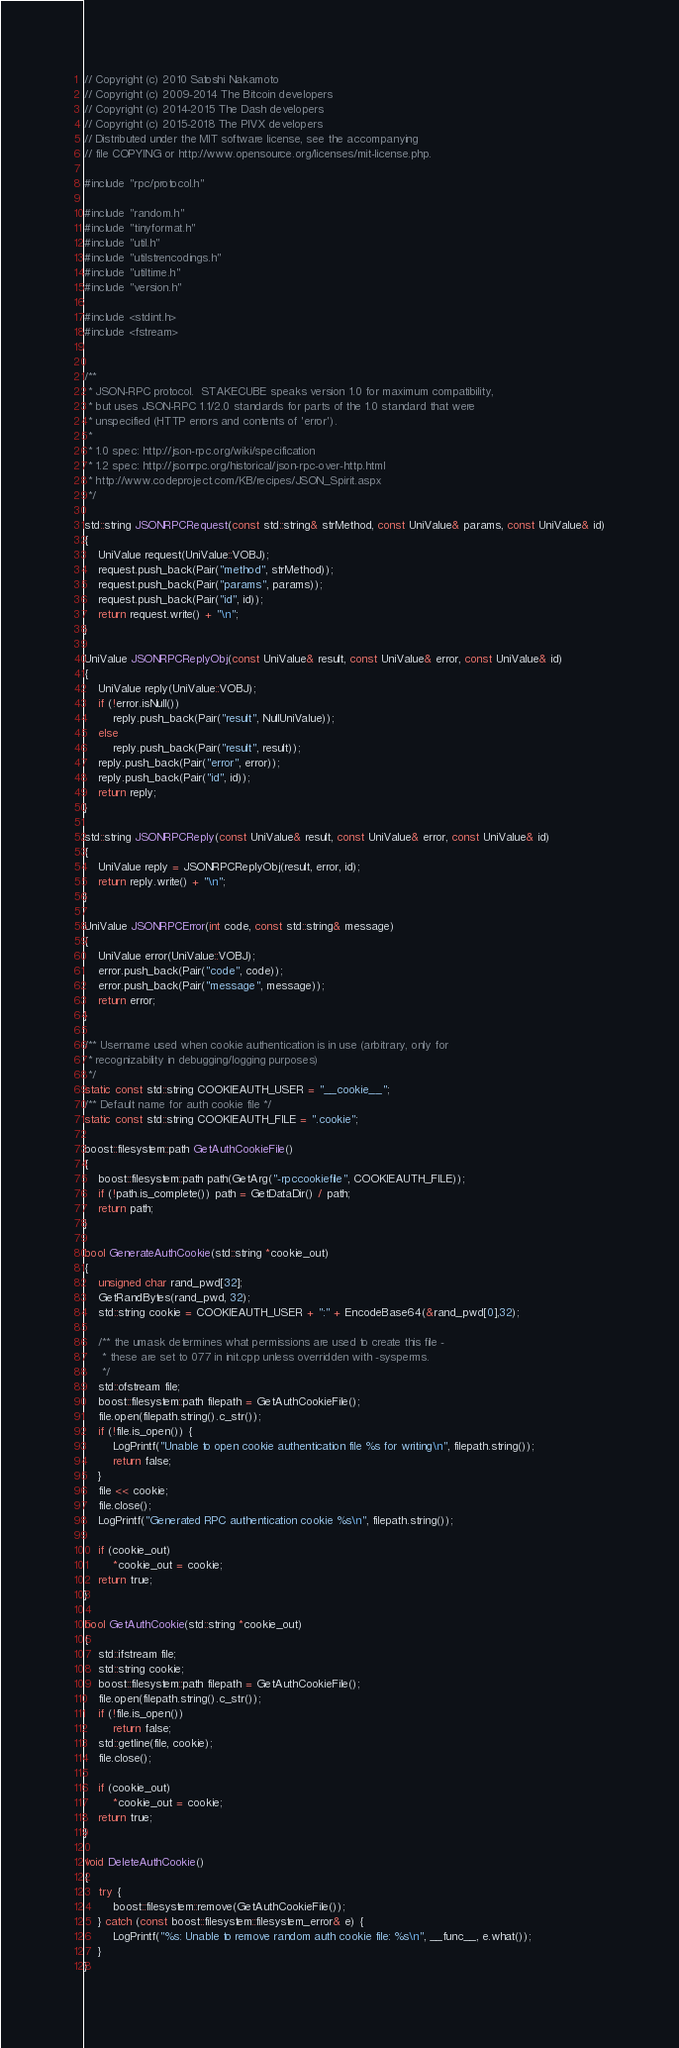Convert code to text. <code><loc_0><loc_0><loc_500><loc_500><_C++_>// Copyright (c) 2010 Satoshi Nakamoto
// Copyright (c) 2009-2014 The Bitcoin developers
// Copyright (c) 2014-2015 The Dash developers
// Copyright (c) 2015-2018 The PIVX developers
// Distributed under the MIT software license, see the accompanying
// file COPYING or http://www.opensource.org/licenses/mit-license.php.

#include "rpc/protocol.h"

#include "random.h"
#include "tinyformat.h"
#include "util.h"
#include "utilstrencodings.h"
#include "utiltime.h"
#include "version.h"

#include <stdint.h>
#include <fstream>


/**
 * JSON-RPC protocol.  STAKECUBE speaks version 1.0 for maximum compatibility,
 * but uses JSON-RPC 1.1/2.0 standards for parts of the 1.0 standard that were
 * unspecified (HTTP errors and contents of 'error').
 *
 * 1.0 spec: http://json-rpc.org/wiki/specification
 * 1.2 spec: http://jsonrpc.org/historical/json-rpc-over-http.html
 * http://www.codeproject.com/KB/recipes/JSON_Spirit.aspx
 */

std::string JSONRPCRequest(const std::string& strMethod, const UniValue& params, const UniValue& id)
{
    UniValue request(UniValue::VOBJ);
    request.push_back(Pair("method", strMethod));
    request.push_back(Pair("params", params));
    request.push_back(Pair("id", id));
    return request.write() + "\n";
}

UniValue JSONRPCReplyObj(const UniValue& result, const UniValue& error, const UniValue& id)
{
    UniValue reply(UniValue::VOBJ);
    if (!error.isNull())
        reply.push_back(Pair("result", NullUniValue));
    else
        reply.push_back(Pair("result", result));
    reply.push_back(Pair("error", error));
    reply.push_back(Pair("id", id));
    return reply;
}

std::string JSONRPCReply(const UniValue& result, const UniValue& error, const UniValue& id)
{
    UniValue reply = JSONRPCReplyObj(result, error, id);
    return reply.write() + "\n";
}

UniValue JSONRPCError(int code, const std::string& message)
{
    UniValue error(UniValue::VOBJ);
    error.push_back(Pair("code", code));
    error.push_back(Pair("message", message));
    return error;
}

/** Username used when cookie authentication is in use (arbitrary, only for
 * recognizability in debugging/logging purposes)
 */
static const std::string COOKIEAUTH_USER = "__cookie__";
/** Default name for auth cookie file */
static const std::string COOKIEAUTH_FILE = ".cookie";

boost::filesystem::path GetAuthCookieFile()
{
    boost::filesystem::path path(GetArg("-rpccookiefile", COOKIEAUTH_FILE));
    if (!path.is_complete()) path = GetDataDir() / path;
    return path;
}

bool GenerateAuthCookie(std::string *cookie_out)
{
    unsigned char rand_pwd[32];
    GetRandBytes(rand_pwd, 32);
    std::string cookie = COOKIEAUTH_USER + ":" + EncodeBase64(&rand_pwd[0],32);

    /** the umask determines what permissions are used to create this file -
     * these are set to 077 in init.cpp unless overridden with -sysperms.
     */
    std::ofstream file;
    boost::filesystem::path filepath = GetAuthCookieFile();
    file.open(filepath.string().c_str());
    if (!file.is_open()) {
        LogPrintf("Unable to open cookie authentication file %s for writing\n", filepath.string());
        return false;
    }
    file << cookie;
    file.close();
    LogPrintf("Generated RPC authentication cookie %s\n", filepath.string());

    if (cookie_out)
        *cookie_out = cookie;
    return true;
}

bool GetAuthCookie(std::string *cookie_out)
{
    std::ifstream file;
    std::string cookie;
    boost::filesystem::path filepath = GetAuthCookieFile();
    file.open(filepath.string().c_str());
    if (!file.is_open())
        return false;
    std::getline(file, cookie);
    file.close();

    if (cookie_out)
        *cookie_out = cookie;
    return true;
}

void DeleteAuthCookie()
{
    try {
        boost::filesystem::remove(GetAuthCookieFile());
    } catch (const boost::filesystem::filesystem_error& e) {
        LogPrintf("%s: Unable to remove random auth cookie file: %s\n", __func__, e.what());
    }
}
</code> 